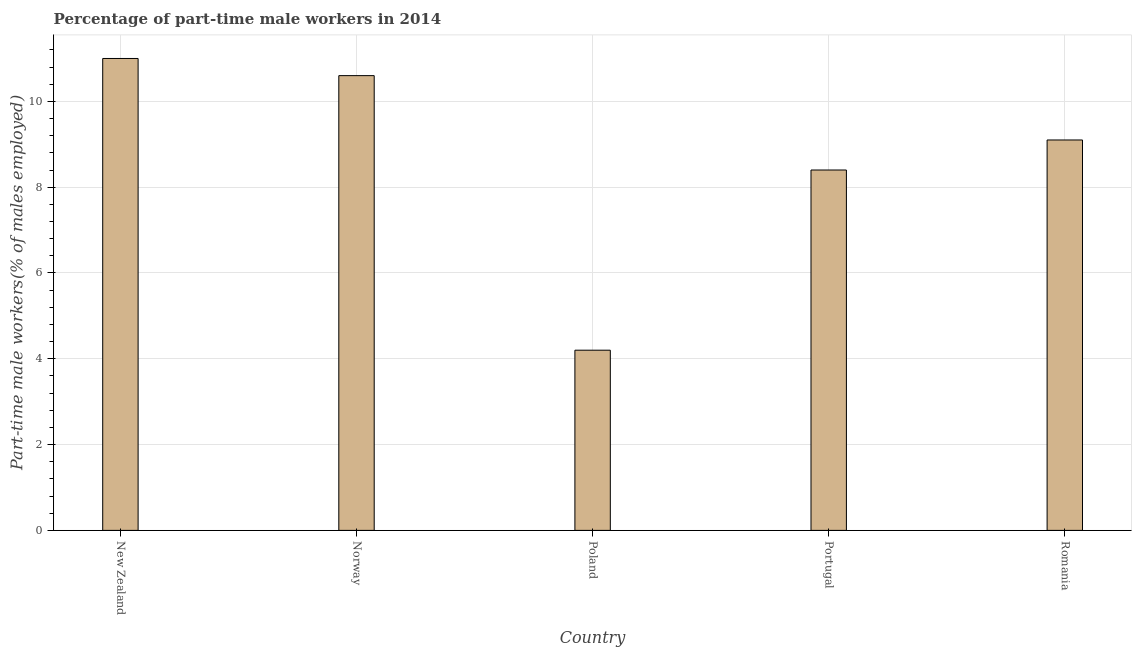What is the title of the graph?
Your answer should be compact. Percentage of part-time male workers in 2014. What is the label or title of the X-axis?
Offer a terse response. Country. What is the label or title of the Y-axis?
Your answer should be compact. Part-time male workers(% of males employed). What is the percentage of part-time male workers in Romania?
Keep it short and to the point. 9.1. Across all countries, what is the minimum percentage of part-time male workers?
Your response must be concise. 4.2. In which country was the percentage of part-time male workers maximum?
Provide a short and direct response. New Zealand. What is the sum of the percentage of part-time male workers?
Your response must be concise. 43.3. What is the difference between the percentage of part-time male workers in New Zealand and Portugal?
Offer a very short reply. 2.6. What is the average percentage of part-time male workers per country?
Your answer should be compact. 8.66. What is the median percentage of part-time male workers?
Offer a very short reply. 9.1. In how many countries, is the percentage of part-time male workers greater than 4 %?
Your response must be concise. 5. What is the ratio of the percentage of part-time male workers in New Zealand to that in Portugal?
Provide a succinct answer. 1.31. What is the difference between the highest and the second highest percentage of part-time male workers?
Offer a very short reply. 0.4. How many bars are there?
Give a very brief answer. 5. How many countries are there in the graph?
Ensure brevity in your answer.  5. Are the values on the major ticks of Y-axis written in scientific E-notation?
Keep it short and to the point. No. What is the Part-time male workers(% of males employed) of Norway?
Make the answer very short. 10.6. What is the Part-time male workers(% of males employed) in Poland?
Your answer should be very brief. 4.2. What is the Part-time male workers(% of males employed) in Portugal?
Provide a succinct answer. 8.4. What is the Part-time male workers(% of males employed) of Romania?
Provide a succinct answer. 9.1. What is the difference between the Part-time male workers(% of males employed) in New Zealand and Norway?
Provide a succinct answer. 0.4. What is the difference between the Part-time male workers(% of males employed) in New Zealand and Poland?
Offer a very short reply. 6.8. What is the difference between the Part-time male workers(% of males employed) in New Zealand and Portugal?
Your answer should be very brief. 2.6. What is the difference between the Part-time male workers(% of males employed) in New Zealand and Romania?
Your answer should be compact. 1.9. What is the difference between the Part-time male workers(% of males employed) in Norway and Poland?
Provide a succinct answer. 6.4. What is the difference between the Part-time male workers(% of males employed) in Norway and Portugal?
Give a very brief answer. 2.2. What is the difference between the Part-time male workers(% of males employed) in Poland and Portugal?
Give a very brief answer. -4.2. What is the ratio of the Part-time male workers(% of males employed) in New Zealand to that in Norway?
Your response must be concise. 1.04. What is the ratio of the Part-time male workers(% of males employed) in New Zealand to that in Poland?
Make the answer very short. 2.62. What is the ratio of the Part-time male workers(% of males employed) in New Zealand to that in Portugal?
Your answer should be compact. 1.31. What is the ratio of the Part-time male workers(% of males employed) in New Zealand to that in Romania?
Provide a short and direct response. 1.21. What is the ratio of the Part-time male workers(% of males employed) in Norway to that in Poland?
Give a very brief answer. 2.52. What is the ratio of the Part-time male workers(% of males employed) in Norway to that in Portugal?
Your answer should be compact. 1.26. What is the ratio of the Part-time male workers(% of males employed) in Norway to that in Romania?
Your answer should be compact. 1.17. What is the ratio of the Part-time male workers(% of males employed) in Poland to that in Romania?
Provide a short and direct response. 0.46. What is the ratio of the Part-time male workers(% of males employed) in Portugal to that in Romania?
Offer a very short reply. 0.92. 